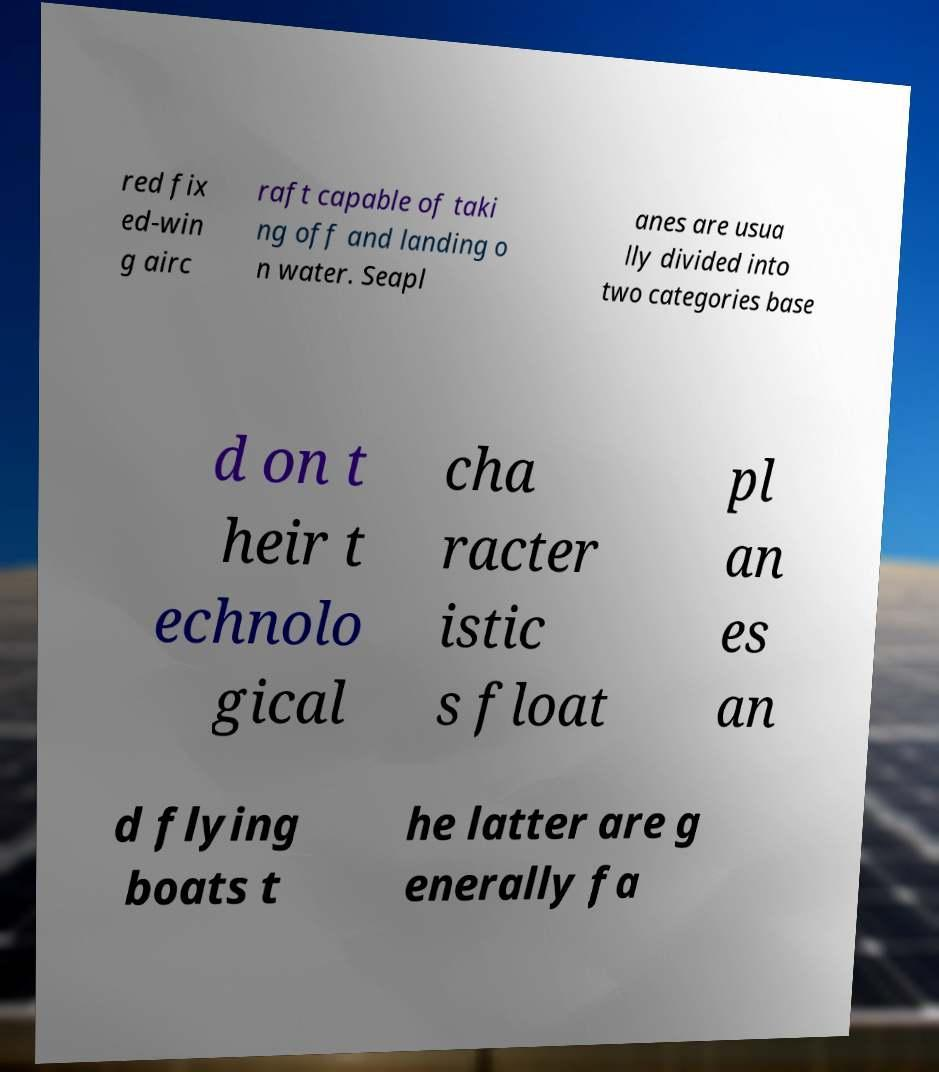Can you read and provide the text displayed in the image?This photo seems to have some interesting text. Can you extract and type it out for me? red fix ed-win g airc raft capable of taki ng off and landing o n water. Seapl anes are usua lly divided into two categories base d on t heir t echnolo gical cha racter istic s float pl an es an d flying boats t he latter are g enerally fa 